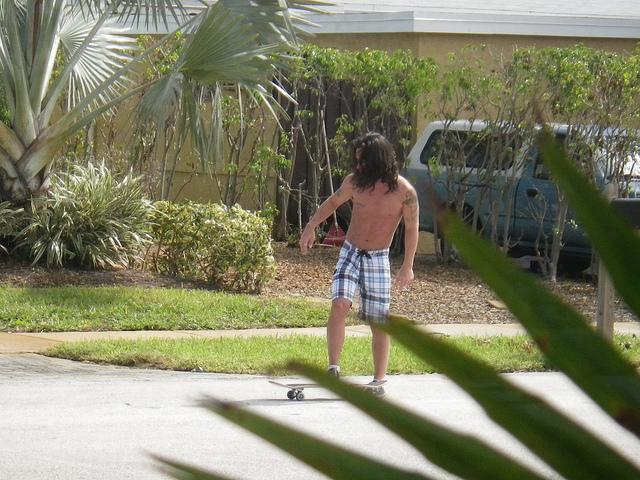What pattern is on the shorts?
Give a very brief answer. Plaid. What color is the truck?
Short answer required. Blue. Is that a boy or girl?
Be succinct. Boy. 